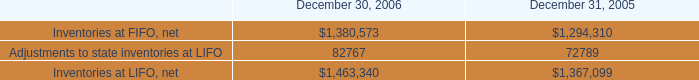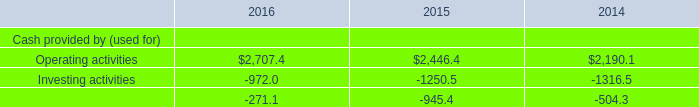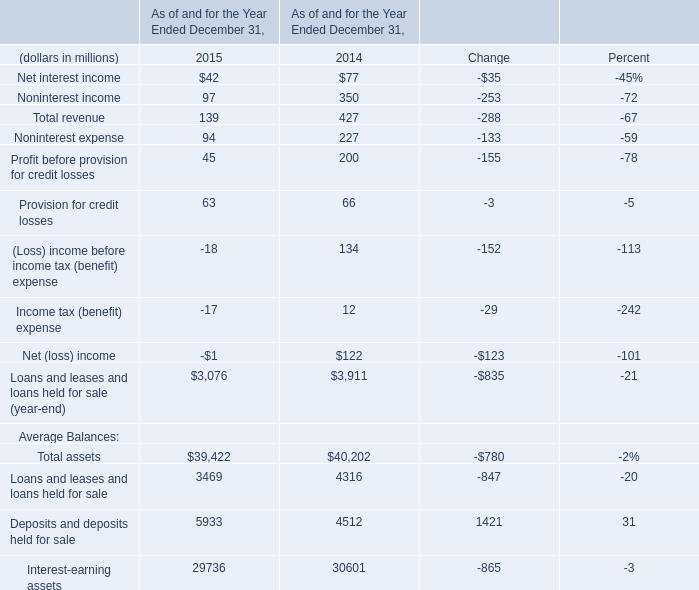In what year is Income tax (benefit) expense positive? 
Answer: 2014. 